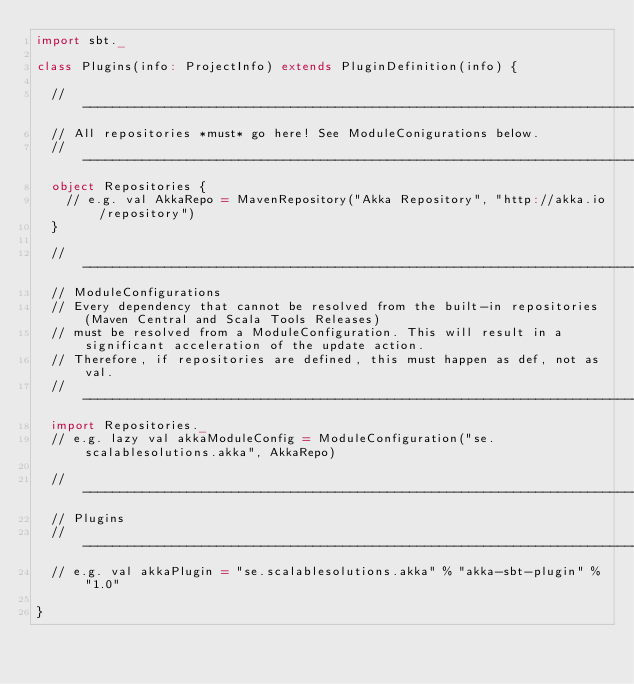<code> <loc_0><loc_0><loc_500><loc_500><_Scala_>import sbt._

class Plugins(info: ProjectInfo) extends PluginDefinition(info) {
  
  // -------------------------------------------------------------------------------------------------------------------
  // All repositories *must* go here! See ModuleConigurations below.
  // -------------------------------------------------------------------------------------------------------------------
  object Repositories {
    // e.g. val AkkaRepo = MavenRepository("Akka Repository", "http://akka.io/repository")
  }
  
  // -------------------------------------------------------------------------------------------------------------------
  // ModuleConfigurations
  // Every dependency that cannot be resolved from the built-in repositories (Maven Central and Scala Tools Releases)
  // must be resolved from a ModuleConfiguration. This will result in a significant acceleration of the update action.
  // Therefore, if repositories are defined, this must happen as def, not as val.
  // -------------------------------------------------------------------------------------------------------------------
  import Repositories._
  // e.g. lazy val akkaModuleConfig = ModuleConfiguration("se.scalablesolutions.akka", AkkaRepo)

  // -------------------------------------------------------------------------------------------------------------------
  // Plugins
  // -------------------------------------------------------------------------------------------------------------------
  // e.g. val akkaPlugin = "se.scalablesolutions.akka" % "akka-sbt-plugin" % "1.0"
  
}
</code> 